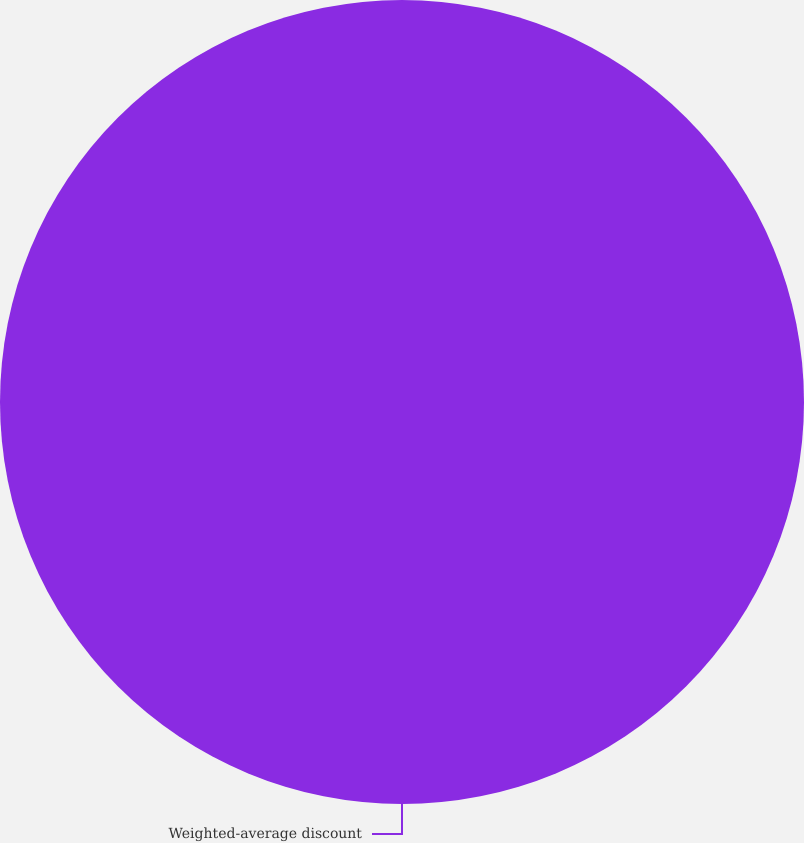<chart> <loc_0><loc_0><loc_500><loc_500><pie_chart><fcel>Weighted-average discount<nl><fcel>100.0%<nl></chart> 